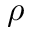<formula> <loc_0><loc_0><loc_500><loc_500>\rho</formula> 